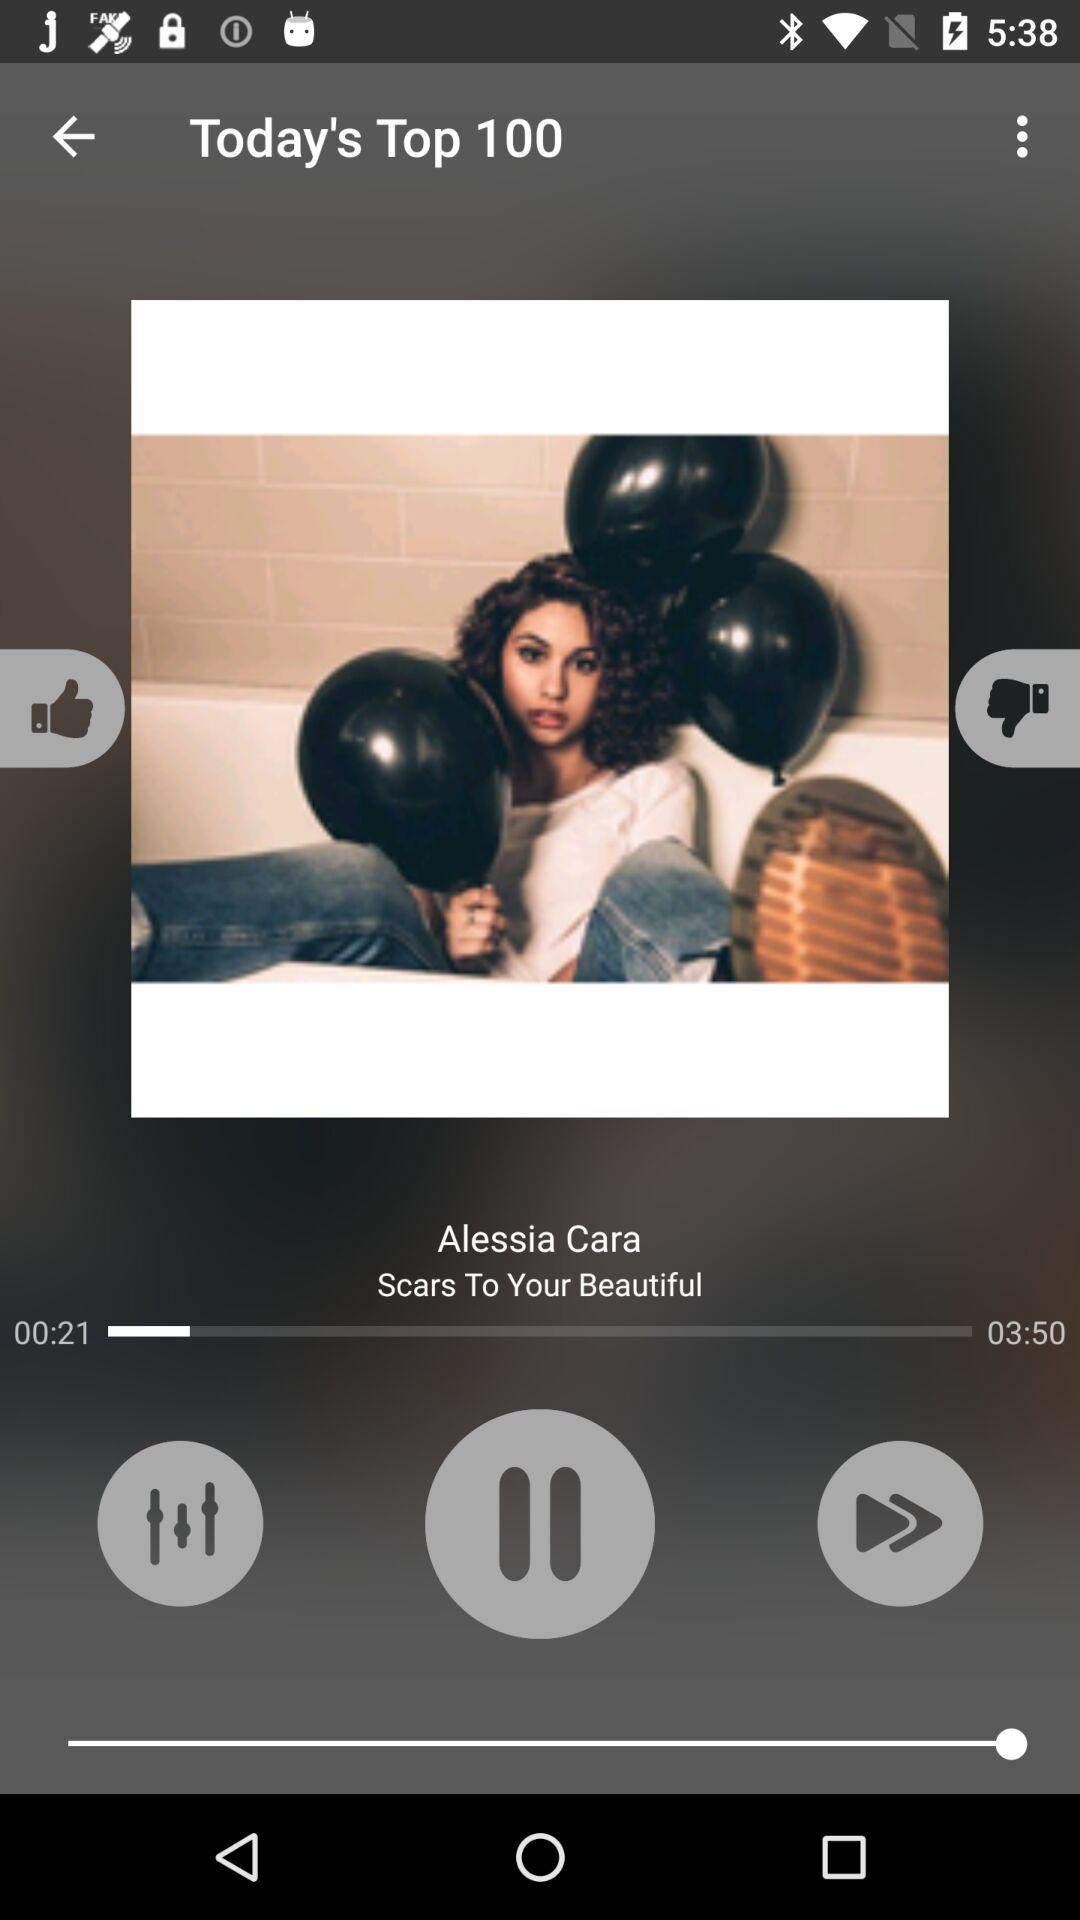Which song is currently playing? The currently playing song is "Scars To Your Beautiful". 